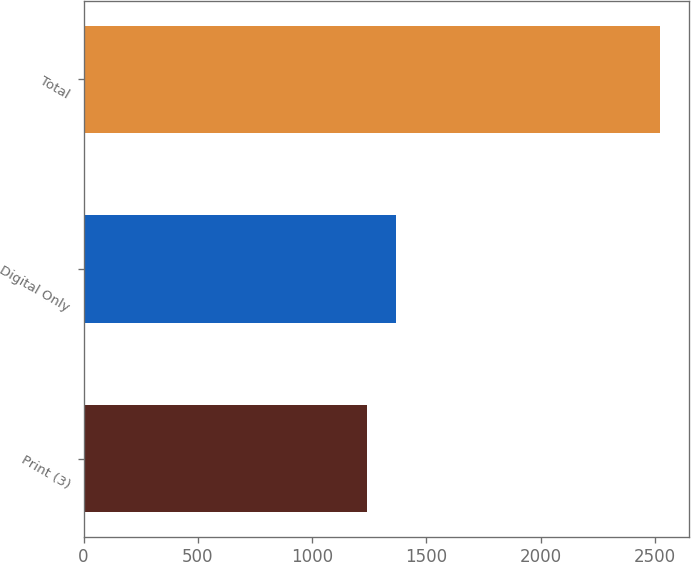Convert chart to OTSL. <chart><loc_0><loc_0><loc_500><loc_500><bar_chart><fcel>Print (3)<fcel>Digital Only<fcel>Total<nl><fcel>1240<fcel>1368.1<fcel>2521<nl></chart> 